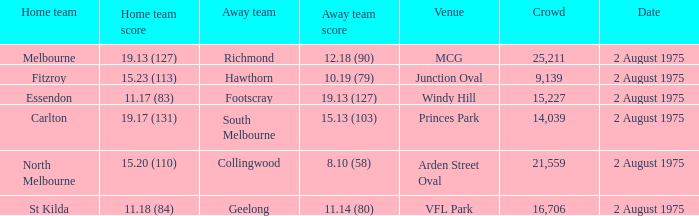Where did the home team score 11.18 (84)? VFL Park. 